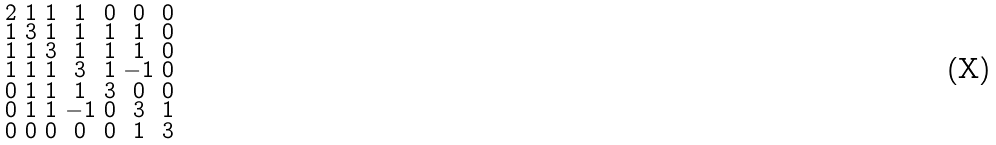<formula> <loc_0><loc_0><loc_500><loc_500>\begin{smallmatrix} 2 & 1 & 1 & 1 & 0 & 0 & 0 \\ 1 & 3 & 1 & 1 & 1 & 1 & 0 \\ 1 & 1 & 3 & 1 & 1 & 1 & 0 \\ 1 & 1 & 1 & 3 & 1 & - 1 & 0 \\ 0 & 1 & 1 & 1 & 3 & 0 & 0 \\ 0 & 1 & 1 & - 1 & 0 & 3 & 1 \\ 0 & 0 & 0 & 0 & 0 & 1 & 3 \end{smallmatrix}</formula> 